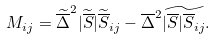Convert formula to latex. <formula><loc_0><loc_0><loc_500><loc_500>M _ { i j } = \widetilde { \overline { \Delta } } ^ { 2 } | \widetilde { \overline { S } } | \widetilde { \overline { S } } _ { i j } - \overline { \Delta } ^ { 2 } \widetilde { | \overline { S } | \overline { S } _ { i j } } .</formula> 